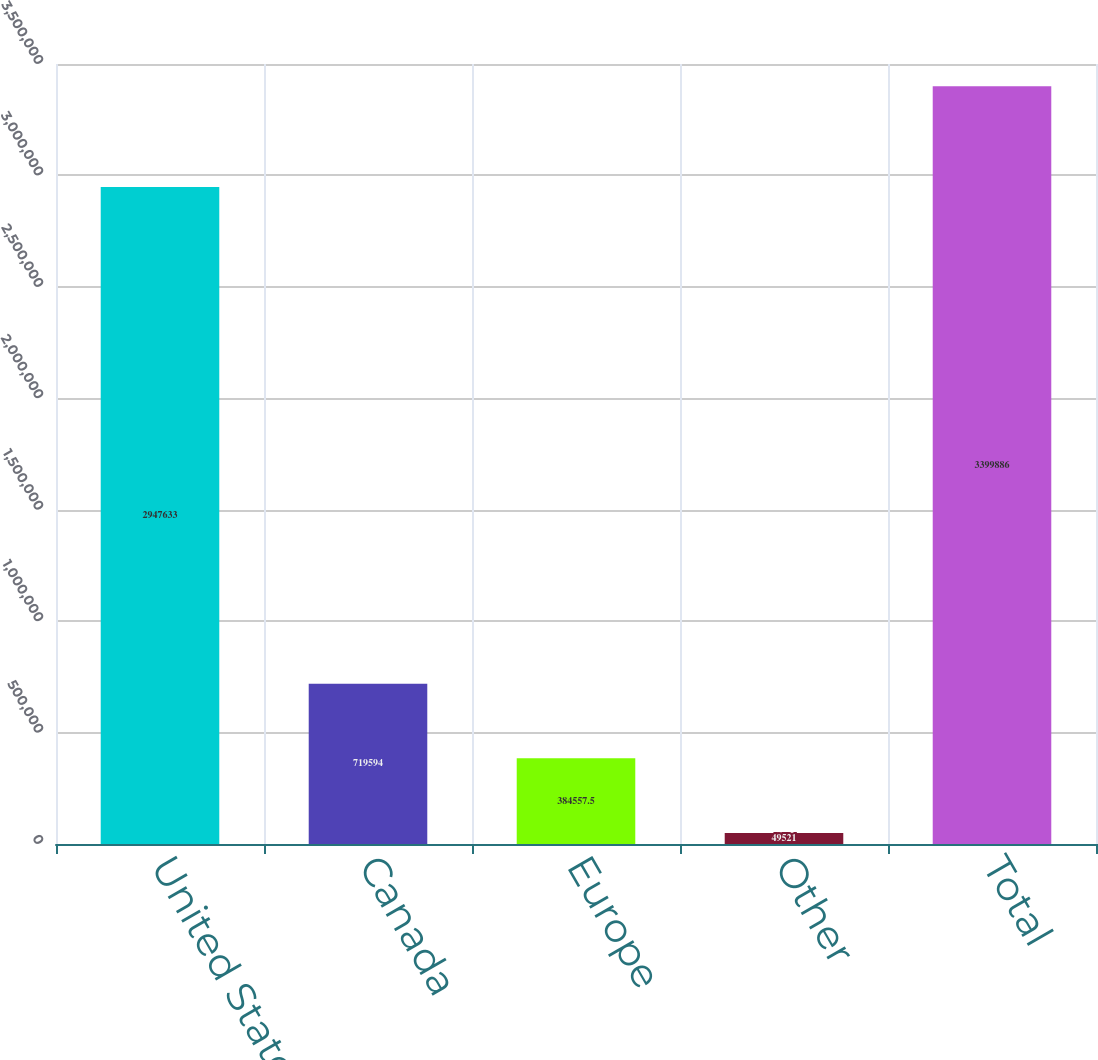<chart> <loc_0><loc_0><loc_500><loc_500><bar_chart><fcel>United States<fcel>Canada<fcel>Europe<fcel>Other<fcel>Total<nl><fcel>2.94763e+06<fcel>719594<fcel>384558<fcel>49521<fcel>3.39989e+06<nl></chart> 